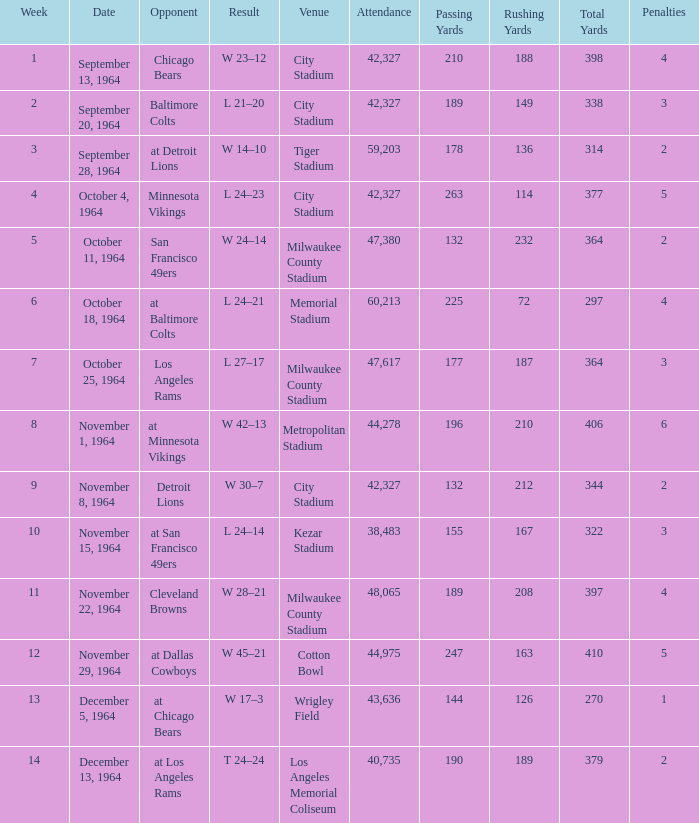What venue held that game with a result of l 24–14? Kezar Stadium. 